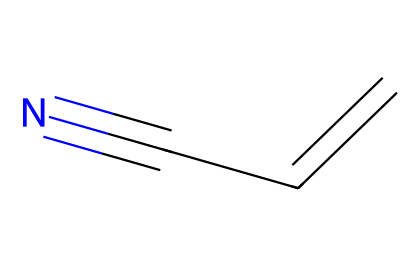How many carbon atoms are in acrylonitrile? The structure of acrylonitrile (C=CC#N) includes two carbon atoms in the double bond (C=C) and one in the nitrile (C#N). Therefore, there are a total of three carbon atoms in acrylonitrile.
Answer: three What type of functional group is present in acrylonitrile? The presence of a nitrile group, indicated by the triple bond between carbon and nitrogen (C#N), identifies the functional group in acrylonitrile.
Answer: nitrile How many double bonds are in the structure of acrylonitrile? The structure shows one double bond between the two carbon atoms (C=C), thus confirming that there is one double bond present.
Answer: one What is the total number of hydrogen atoms in acrylonitrile? The two carbon atoms are connected by a double bond, and one carbon is connected to a nitrile. Using the formula for hydrogen saturation, C3H5, we determine that there are five hydrogen atoms attached.
Answer: five What could be a potential use of acrylonitrile in neurotransmitter analog synthesis? Acrylonitrile is a precursor in the synthesis of neurotransmitter analogs due to its reactivity and ability to incorporate into larger molecular structures that resemble neurotransmitters.
Answer: neurotransmitter analogs Why is the nitrile group significant in the context of neuroactive compounds? The nitrile group (-C#N) can affect the electronic properties of the molecule and influence binding affinity at neural receptors, making it significant for developing neuroactive compounds.
Answer: electronic properties 